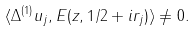<formula> <loc_0><loc_0><loc_500><loc_500>\langle \Delta ^ { ( 1 ) } u _ { j } , E ( z , 1 / 2 + i r _ { j } ) \rangle \ne 0 .</formula> 